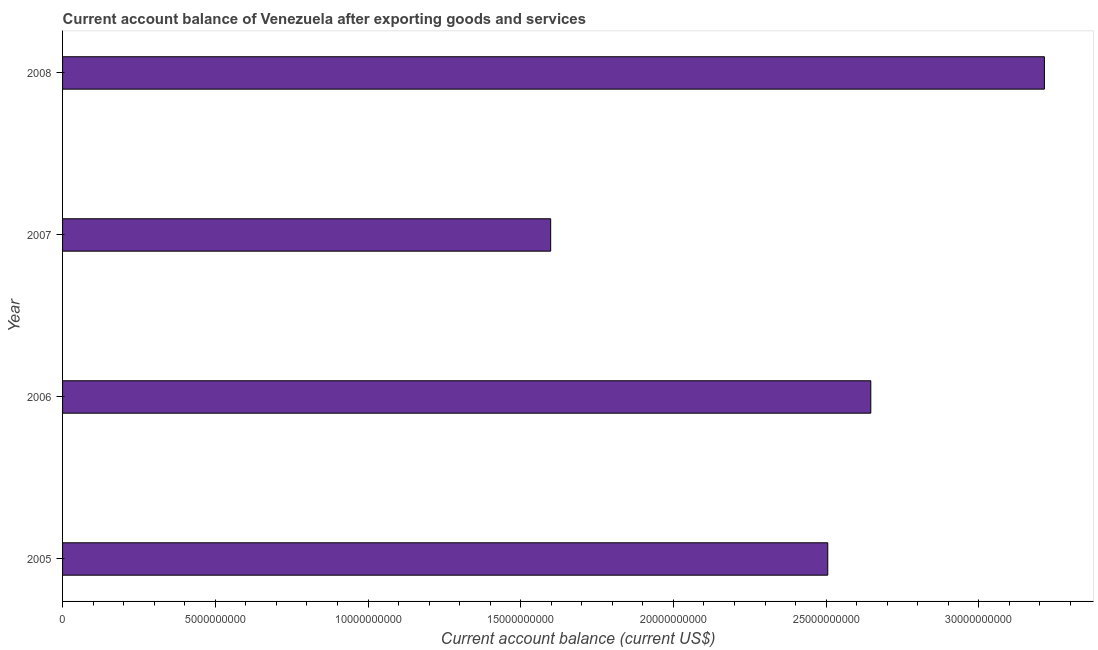Does the graph contain grids?
Provide a short and direct response. No. What is the title of the graph?
Ensure brevity in your answer.  Current account balance of Venezuela after exporting goods and services. What is the label or title of the X-axis?
Provide a short and direct response. Current account balance (current US$). What is the label or title of the Y-axis?
Provide a short and direct response. Year. What is the current account balance in 2008?
Make the answer very short. 3.21e+1. Across all years, what is the maximum current account balance?
Give a very brief answer. 3.21e+1. Across all years, what is the minimum current account balance?
Your answer should be compact. 1.60e+1. In which year was the current account balance maximum?
Offer a very short reply. 2008. In which year was the current account balance minimum?
Provide a succinct answer. 2007. What is the sum of the current account balance?
Provide a succinct answer. 9.96e+1. What is the difference between the current account balance in 2007 and 2008?
Keep it short and to the point. -1.62e+1. What is the average current account balance per year?
Your answer should be compact. 2.49e+1. What is the median current account balance?
Your response must be concise. 2.58e+1. In how many years, is the current account balance greater than 14000000000 US$?
Provide a short and direct response. 4. What is the ratio of the current account balance in 2006 to that in 2007?
Make the answer very short. 1.66. Is the current account balance in 2005 less than that in 2006?
Provide a short and direct response. Yes. What is the difference between the highest and the second highest current account balance?
Make the answer very short. 5.68e+09. What is the difference between the highest and the lowest current account balance?
Ensure brevity in your answer.  1.62e+1. In how many years, is the current account balance greater than the average current account balance taken over all years?
Offer a terse response. 3. Are all the bars in the graph horizontal?
Provide a short and direct response. Yes. What is the Current account balance (current US$) of 2005?
Provide a succinct answer. 2.51e+1. What is the Current account balance (current US$) of 2006?
Provide a succinct answer. 2.65e+1. What is the Current account balance (current US$) in 2007?
Keep it short and to the point. 1.60e+1. What is the Current account balance (current US$) of 2008?
Your answer should be compact. 3.21e+1. What is the difference between the Current account balance (current US$) in 2005 and 2006?
Your answer should be compact. -1.41e+09. What is the difference between the Current account balance (current US$) in 2005 and 2007?
Provide a succinct answer. 9.07e+09. What is the difference between the Current account balance (current US$) in 2005 and 2008?
Your answer should be compact. -7.09e+09. What is the difference between the Current account balance (current US$) in 2006 and 2007?
Give a very brief answer. 1.05e+1. What is the difference between the Current account balance (current US$) in 2006 and 2008?
Offer a very short reply. -5.68e+09. What is the difference between the Current account balance (current US$) in 2007 and 2008?
Offer a terse response. -1.62e+1. What is the ratio of the Current account balance (current US$) in 2005 to that in 2006?
Your answer should be very brief. 0.95. What is the ratio of the Current account balance (current US$) in 2005 to that in 2007?
Your response must be concise. 1.57. What is the ratio of the Current account balance (current US$) in 2005 to that in 2008?
Offer a terse response. 0.78. What is the ratio of the Current account balance (current US$) in 2006 to that in 2007?
Offer a terse response. 1.66. What is the ratio of the Current account balance (current US$) in 2006 to that in 2008?
Provide a short and direct response. 0.82. What is the ratio of the Current account balance (current US$) in 2007 to that in 2008?
Your answer should be very brief. 0.5. 